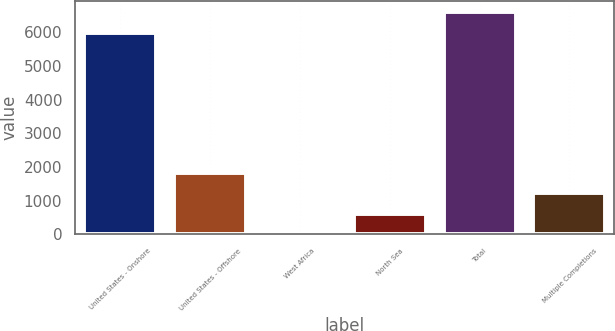<chart> <loc_0><loc_0><loc_500><loc_500><bar_chart><fcel>United States - Onshore<fcel>United States - Offshore<fcel>West Africa<fcel>North Sea<fcel>Total<fcel>Multiple Completions<nl><fcel>5997.8<fcel>1839.73<fcel>0.4<fcel>613.51<fcel>6610.91<fcel>1226.62<nl></chart> 